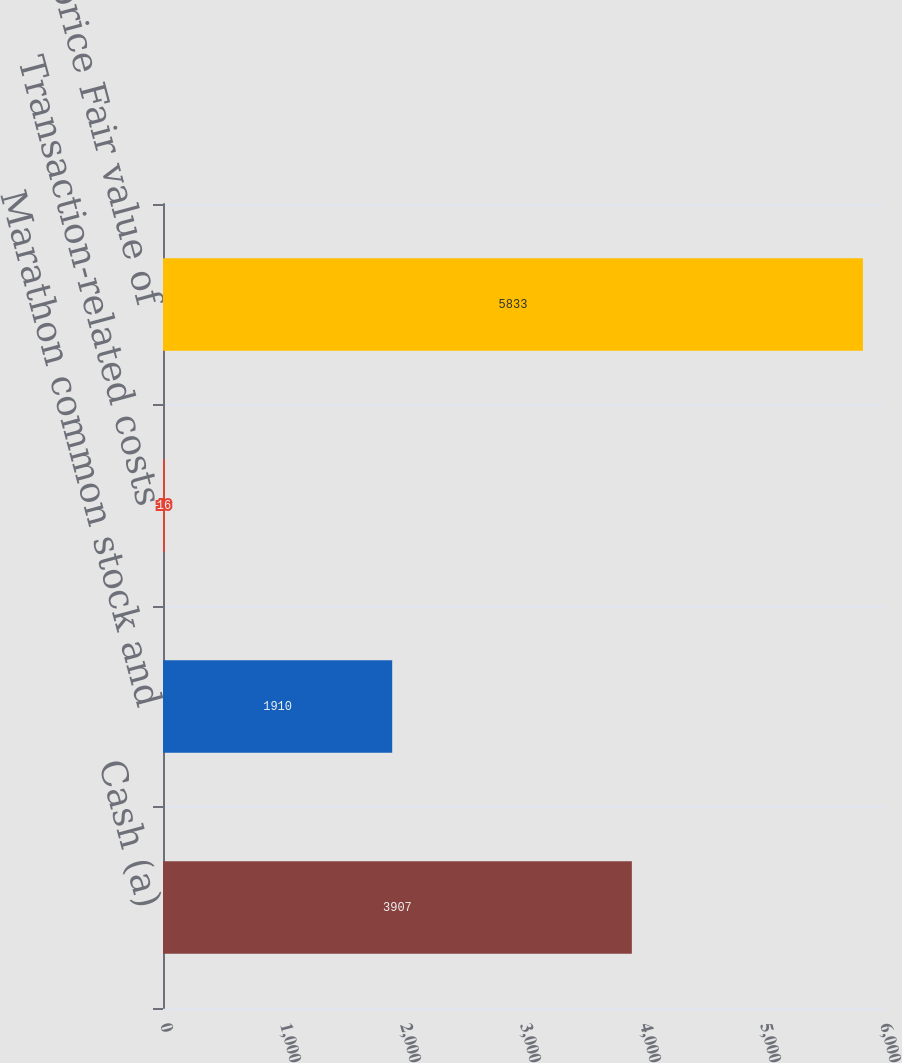<chart> <loc_0><loc_0><loc_500><loc_500><bar_chart><fcel>Cash (a)<fcel>Marathon common stock and<fcel>Transaction-related costs<fcel>Purchase price Fair value of<nl><fcel>3907<fcel>1910<fcel>16<fcel>5833<nl></chart> 